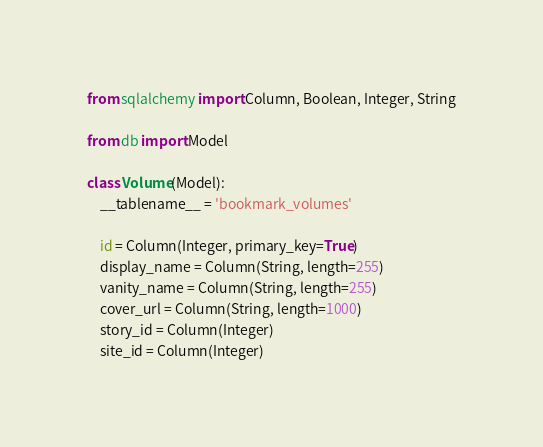Convert code to text. <code><loc_0><loc_0><loc_500><loc_500><_Python_>from sqlalchemy import Column, Boolean, Integer, String

from db import Model

class Volume(Model):
    __tablename__ = 'bookmark_volumes'

    id = Column(Integer, primary_key=True)
    display_name = Column(String, length=255)
    vanity_name = Column(String, length=255)
    cover_url = Column(String, length=1000)
    story_id = Column(Integer)
    site_id = Column(Integer)</code> 